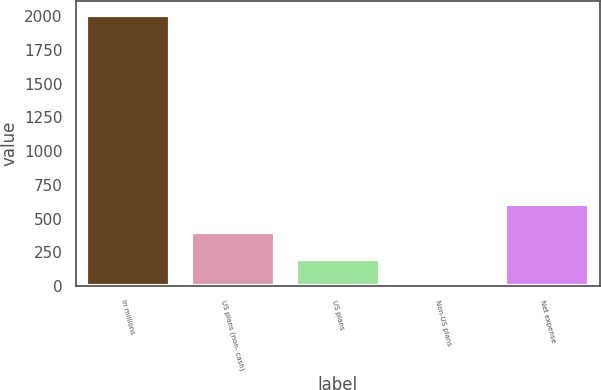Convert chart. <chart><loc_0><loc_0><loc_500><loc_500><bar_chart><fcel>In millions<fcel>US plans (non- cash)<fcel>US plans<fcel>Non-US plans<fcel>Net expense<nl><fcel>2012<fcel>403.2<fcel>202.1<fcel>1<fcel>604.3<nl></chart> 